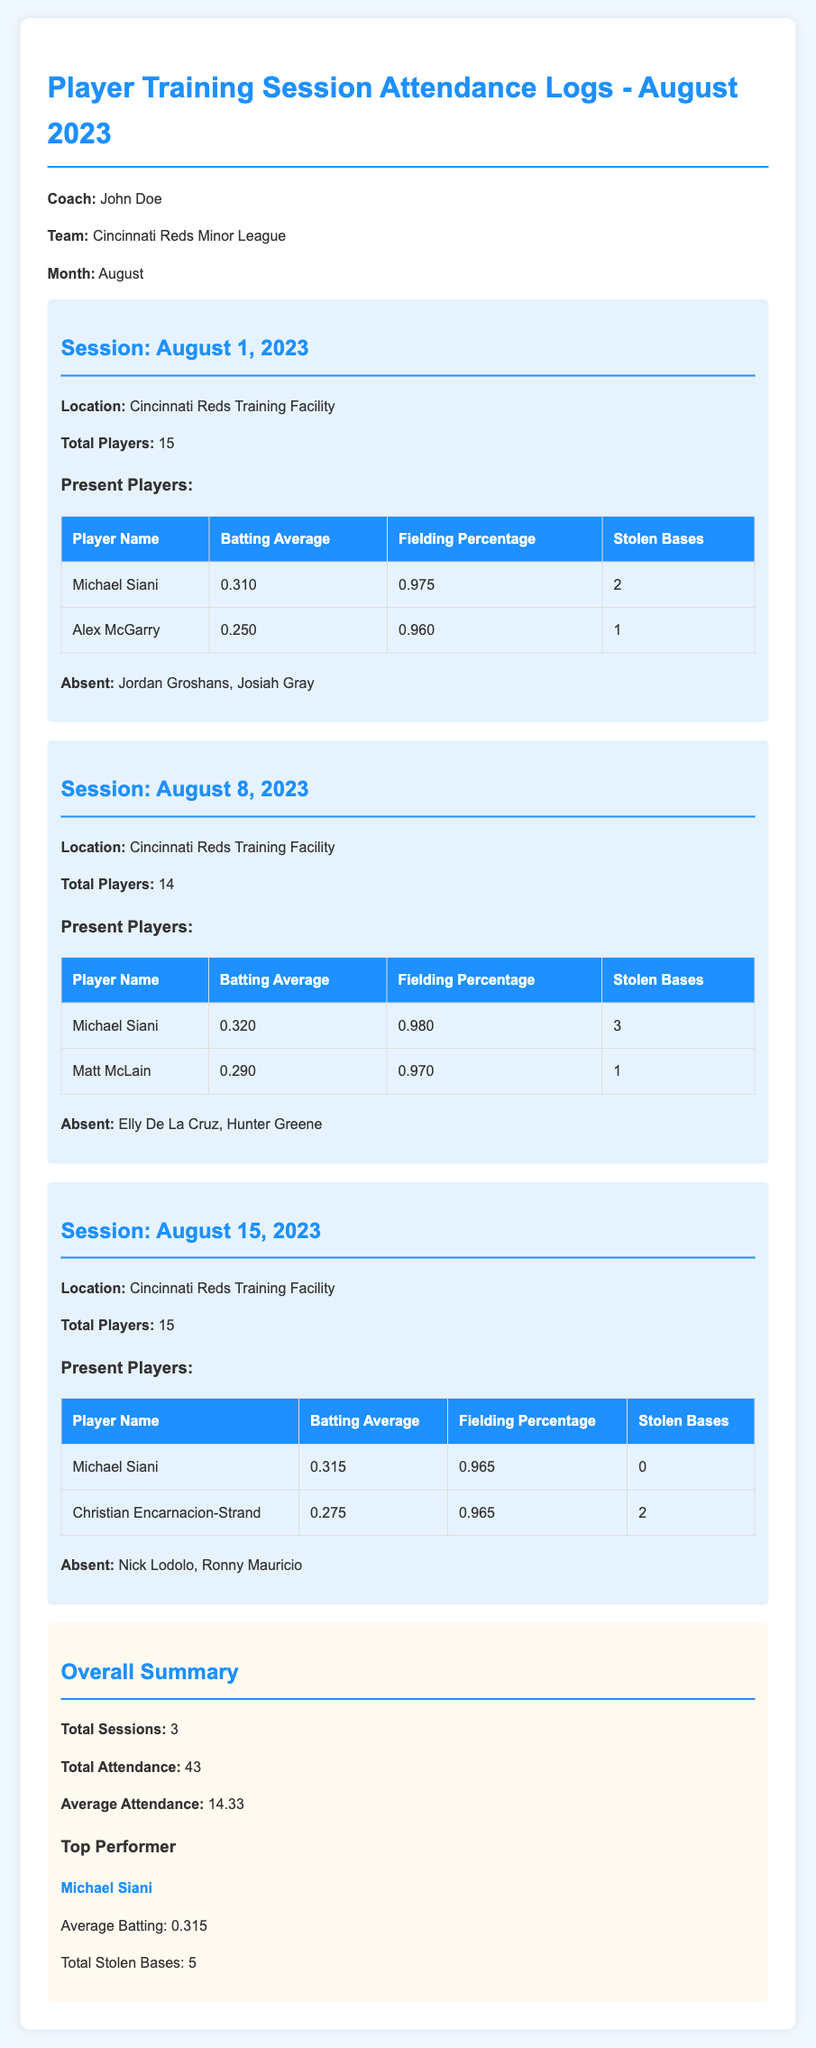What is the total number of players who attended training sessions in August? The total attendance is calculated by adding the number of players present at each session: 15 + 14 + 15 = 44.
Answer: 43 Who had the highest batting average in the training sessions? Michael Siani has the highest batting average calculated from all the sessions attended, with averages of 0.310, 0.320, and 0.315.
Answer: Michael Siani What was Michael Siani's total number of stolen bases for the month? To find Michael Siani's total stolen bases, sum up the individual counts he's participated in at each session: 2 + 3 + 0 = 5.
Answer: 5 How many sessions were held in total during August? The document lists three distinct training sessions that took place in August 2023.
Answer: 3 What is the average attendance per session? The average attendance is calculated by dividing the total attendance by the number of sessions: 43 / 3 = 14.33.
Answer: 14.33 Which players were absent during the August 8 session? The document lists the players who were not present at this session: Elly De La Cruz and Hunter Greene.
Answer: Elly De La Cruz, Hunter Greene What is the location of the training sessions? The location mentioned for all training sessions is the Cincinnati Reds Training Facility.
Answer: Cincinnati Reds Training Facility What was Michael Siani's fielding percentage during the August 15 session? The document specifically states that Michael Siani had a fielding percentage of 0.965 in the session on August 15.
Answer: 0.965 